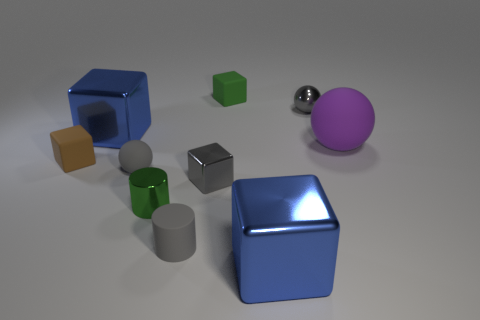Subtract 2 cubes. How many cubes are left? 3 Subtract all gray cubes. How many cubes are left? 4 Subtract all tiny green cubes. How many cubes are left? 4 Subtract all cyan blocks. Subtract all gray spheres. How many blocks are left? 5 Subtract all cylinders. How many objects are left? 8 Subtract 2 blue cubes. How many objects are left? 8 Subtract all big red metal things. Subtract all tiny matte balls. How many objects are left? 9 Add 4 tiny gray cubes. How many tiny gray cubes are left? 5 Add 9 big matte balls. How many big matte balls exist? 10 